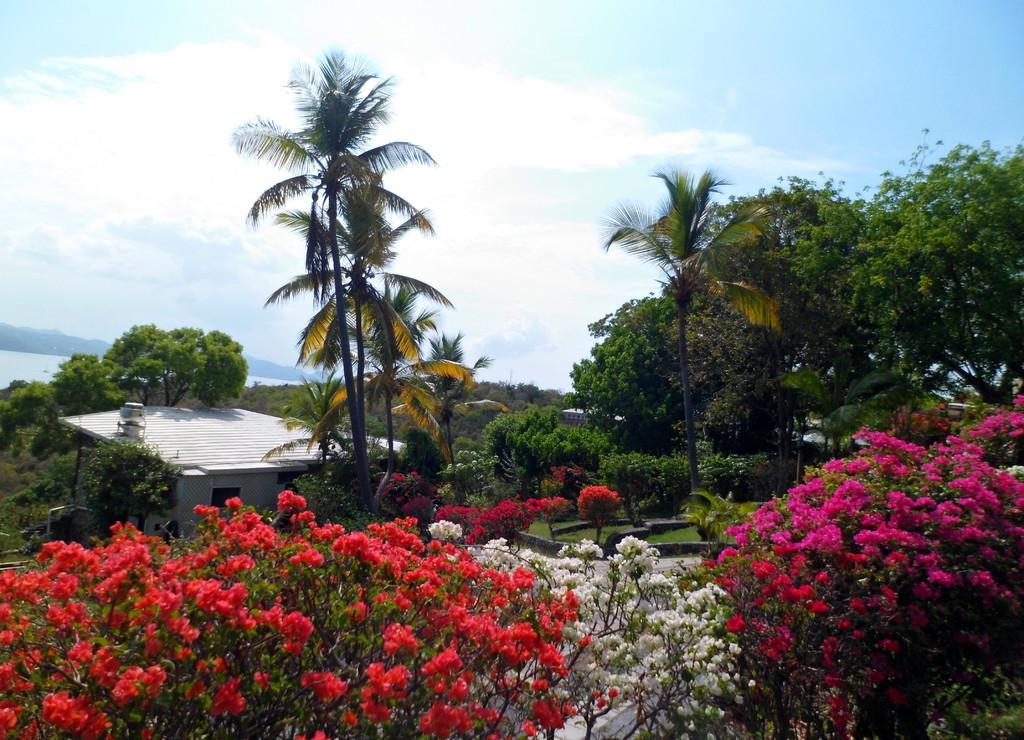Could you give a brief overview of what you see in this image? In this image we can see the trees, plants, grass and also the house. In the background there is sky with the clouds. We can also see the hills and water. At the bottom we can see the flower trees. 